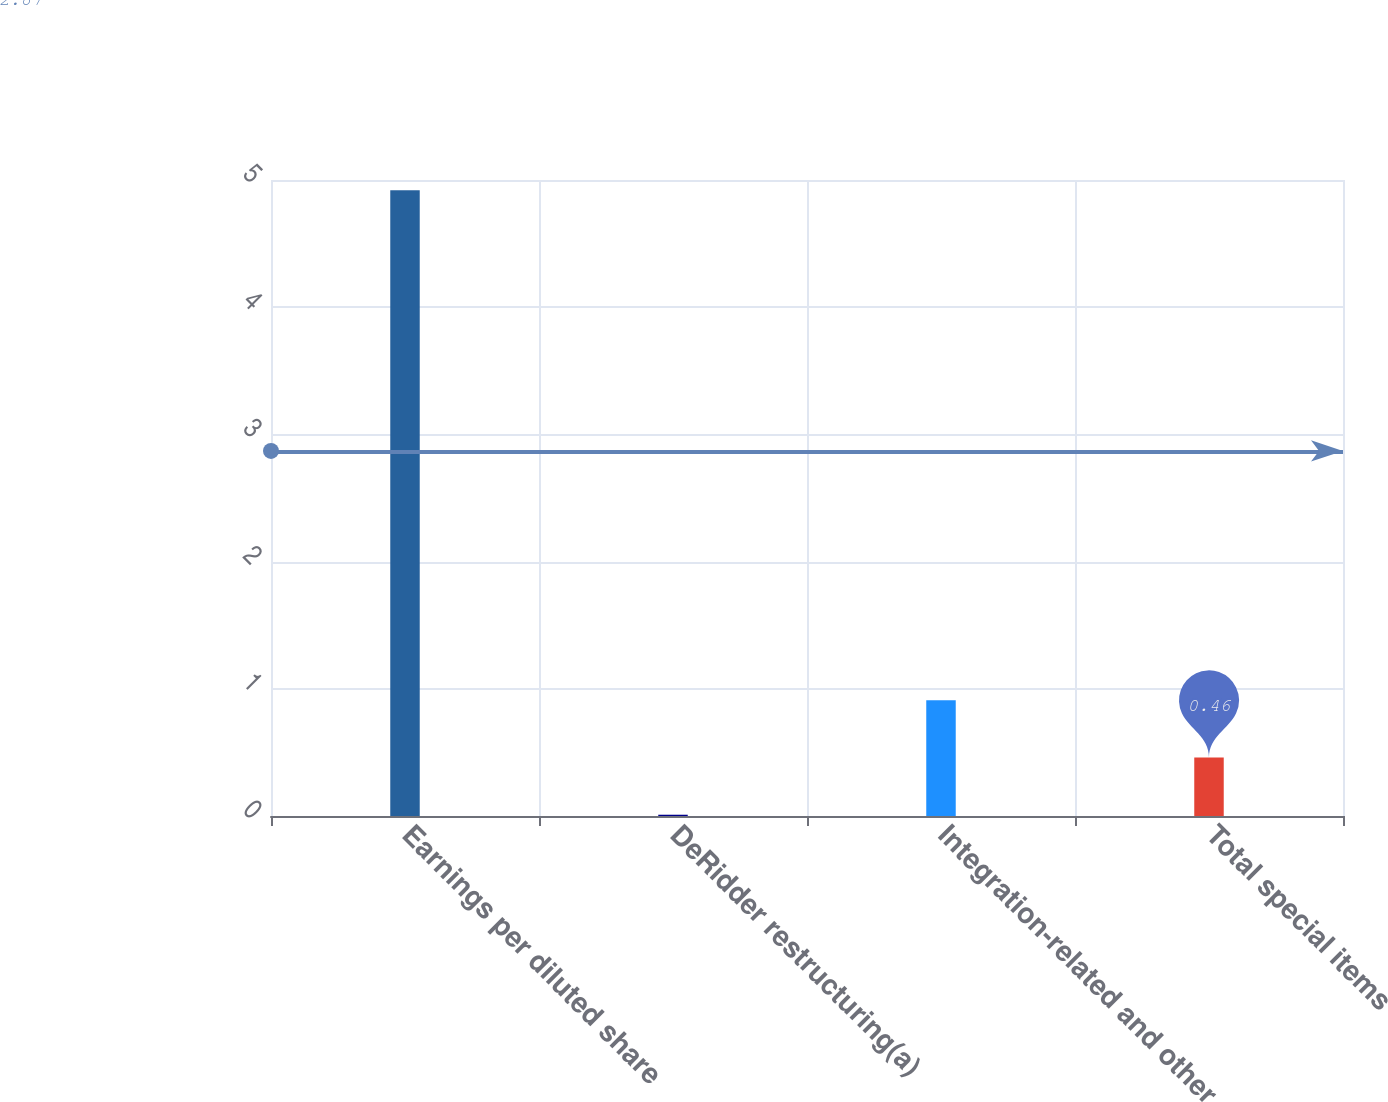Convert chart. <chart><loc_0><loc_0><loc_500><loc_500><bar_chart><fcel>Earnings per diluted share<fcel>DeRidder restructuring(a)<fcel>Integration-related and other<fcel>Total special items<nl><fcel>4.92<fcel>0.01<fcel>0.91<fcel>0.46<nl></chart> 